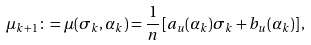Convert formula to latex. <formula><loc_0><loc_0><loc_500><loc_500>\mu _ { k + 1 } \colon = \mu ( \sigma _ { k } , { \alpha } _ { k } ) = \frac { 1 } { n } \left [ a _ { u } ( \alpha _ { k } ) \sigma _ { k } + b _ { u } ( \alpha _ { k } ) \right ] ,</formula> 